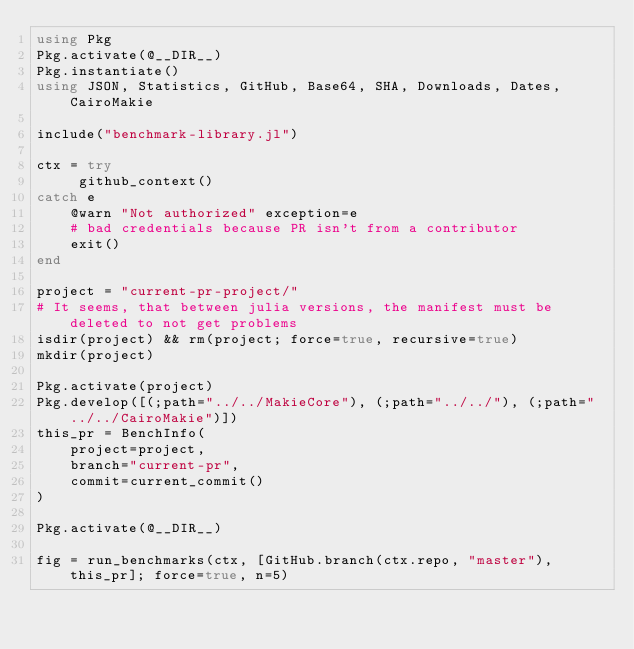<code> <loc_0><loc_0><loc_500><loc_500><_Julia_>using Pkg
Pkg.activate(@__DIR__)
Pkg.instantiate()
using JSON, Statistics, GitHub, Base64, SHA, Downloads, Dates, CairoMakie

include("benchmark-library.jl")

ctx = try
     github_context()
catch e
    @warn "Not authorized" exception=e
    # bad credentials because PR isn't from a contributor
    exit()
end

project = "current-pr-project/"
# It seems, that between julia versions, the manifest must be deleted to not get problems
isdir(project) && rm(project; force=true, recursive=true)
mkdir(project)

Pkg.activate(project)
Pkg.develop([(;path="../../MakieCore"), (;path="../../"), (;path="../../CairoMakie")])
this_pr = BenchInfo(
    project=project,
    branch="current-pr",
    commit=current_commit()
)

Pkg.activate(@__DIR__)

fig = run_benchmarks(ctx, [GitHub.branch(ctx.repo, "master"), this_pr]; force=true, n=5)
</code> 